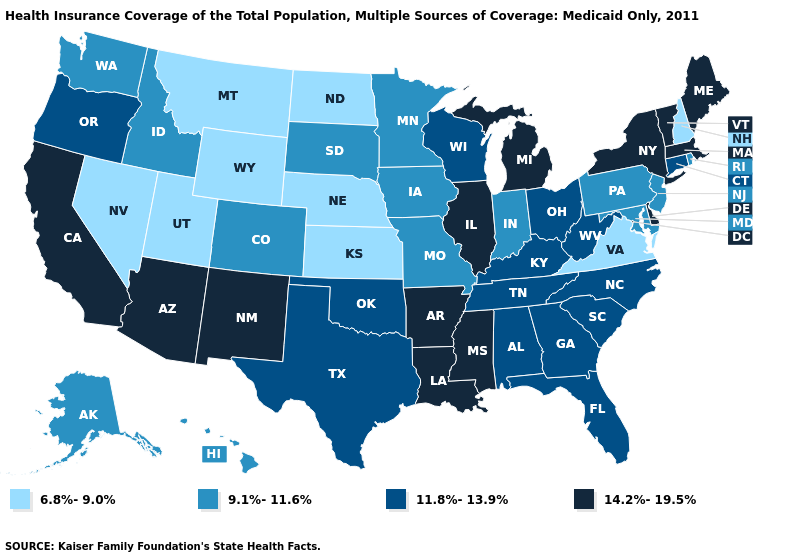Does New Hampshire have the lowest value in the Northeast?
Keep it brief. Yes. What is the value of Montana?
Quick response, please. 6.8%-9.0%. What is the highest value in states that border Wisconsin?
Quick response, please. 14.2%-19.5%. Does Maine have the lowest value in the USA?
Keep it brief. No. Name the states that have a value in the range 14.2%-19.5%?
Quick response, please. Arizona, Arkansas, California, Delaware, Illinois, Louisiana, Maine, Massachusetts, Michigan, Mississippi, New Mexico, New York, Vermont. What is the value of North Carolina?
Give a very brief answer. 11.8%-13.9%. What is the lowest value in the USA?
Short answer required. 6.8%-9.0%. Name the states that have a value in the range 11.8%-13.9%?
Be succinct. Alabama, Connecticut, Florida, Georgia, Kentucky, North Carolina, Ohio, Oklahoma, Oregon, South Carolina, Tennessee, Texas, West Virginia, Wisconsin. Does Pennsylvania have the lowest value in the Northeast?
Write a very short answer. No. Name the states that have a value in the range 11.8%-13.9%?
Concise answer only. Alabama, Connecticut, Florida, Georgia, Kentucky, North Carolina, Ohio, Oklahoma, Oregon, South Carolina, Tennessee, Texas, West Virginia, Wisconsin. Among the states that border Kansas , does Oklahoma have the lowest value?
Give a very brief answer. No. Does Louisiana have the highest value in the USA?
Short answer required. Yes. What is the value of West Virginia?
Be succinct. 11.8%-13.9%. Does the map have missing data?
Quick response, please. No. 